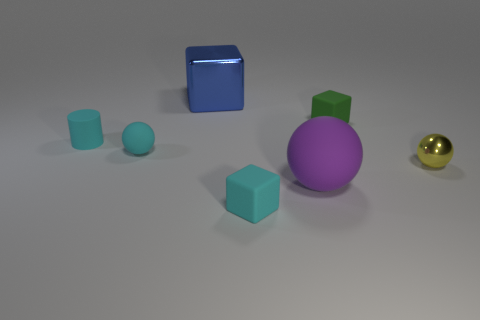Subtract all yellow spheres. How many spheres are left? 2 Subtract all cyan spheres. How many spheres are left? 2 Subtract 0 yellow cylinders. How many objects are left? 7 Subtract all balls. How many objects are left? 4 Subtract 1 cylinders. How many cylinders are left? 0 Subtract all gray spheres. Subtract all green blocks. How many spheres are left? 3 Subtract all gray blocks. How many yellow cylinders are left? 0 Subtract all large red things. Subtract all small matte spheres. How many objects are left? 6 Add 6 tiny cyan objects. How many tiny cyan objects are left? 9 Add 2 tiny red metal cylinders. How many tiny red metal cylinders exist? 2 